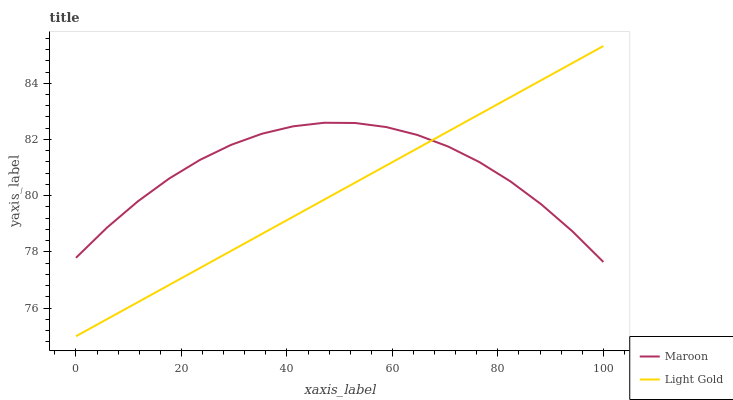Does Maroon have the minimum area under the curve?
Answer yes or no. No. Is Maroon the smoothest?
Answer yes or no. No. Does Maroon have the lowest value?
Answer yes or no. No. Does Maroon have the highest value?
Answer yes or no. No. 